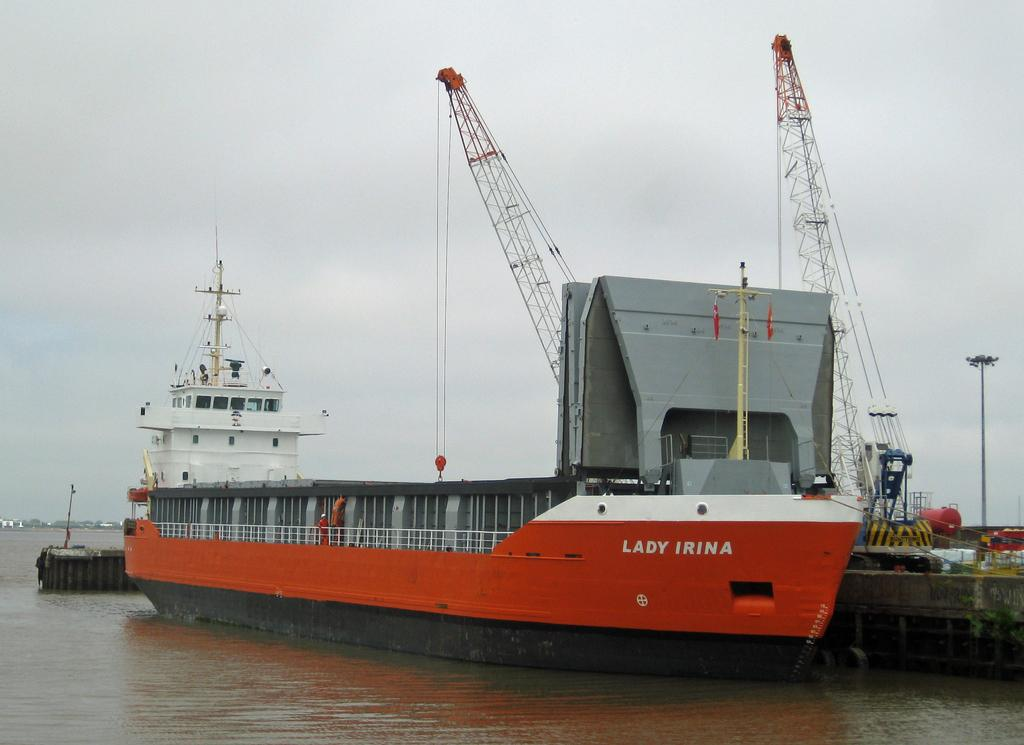<image>
Create a compact narrative representing the image presented. Lady Irina ship that is on the water sailing 